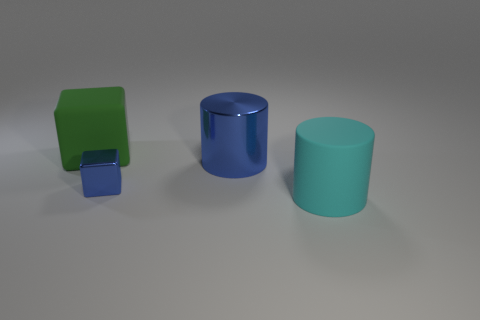Do the big cylinder that is to the left of the large cyan matte thing and the metal block that is left of the large blue thing have the same color?
Your answer should be compact. Yes. How many other objects are there of the same size as the green rubber thing?
Make the answer very short. 2. Is there a green cube to the left of the cylinder that is left of the matte object in front of the big block?
Offer a very short reply. Yes. Does the thing in front of the small shiny block have the same material as the tiny blue block?
Your answer should be compact. No. There is a large object that is the same shape as the small metal thing; what is its color?
Your answer should be compact. Green. Are there an equal number of tiny blocks that are on the left side of the green rubber thing and cylinders?
Ensure brevity in your answer.  No. Are there any matte things left of the tiny shiny thing?
Your answer should be compact. Yes. There is a matte thing in front of the large matte object that is left of the matte object that is in front of the large green block; what size is it?
Your answer should be very brief. Large. There is a blue object that is right of the tiny shiny cube; is it the same shape as the matte object on the left side of the blue shiny cube?
Offer a terse response. No. The blue thing that is the same shape as the large green object is what size?
Give a very brief answer. Small. 